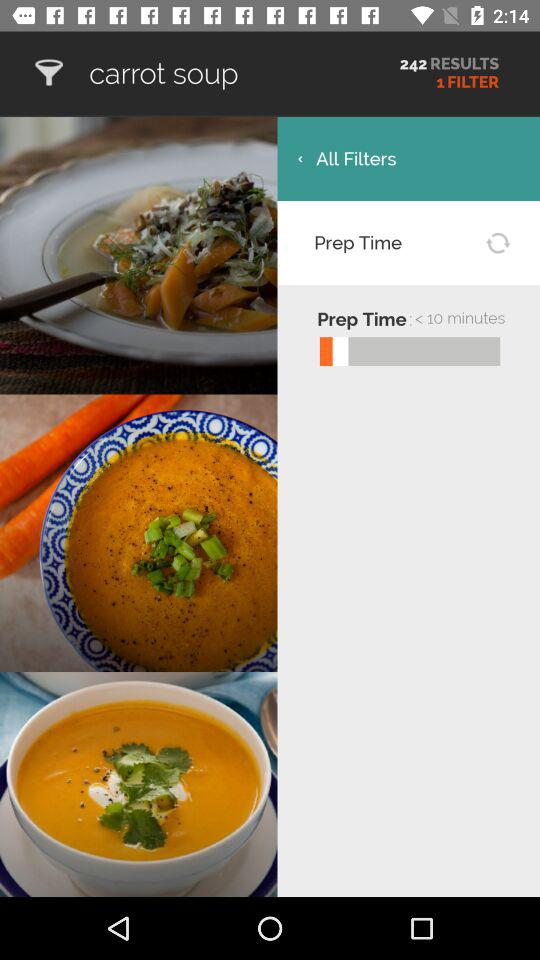How many filters are there?
Answer the question using a single word or phrase. 1 